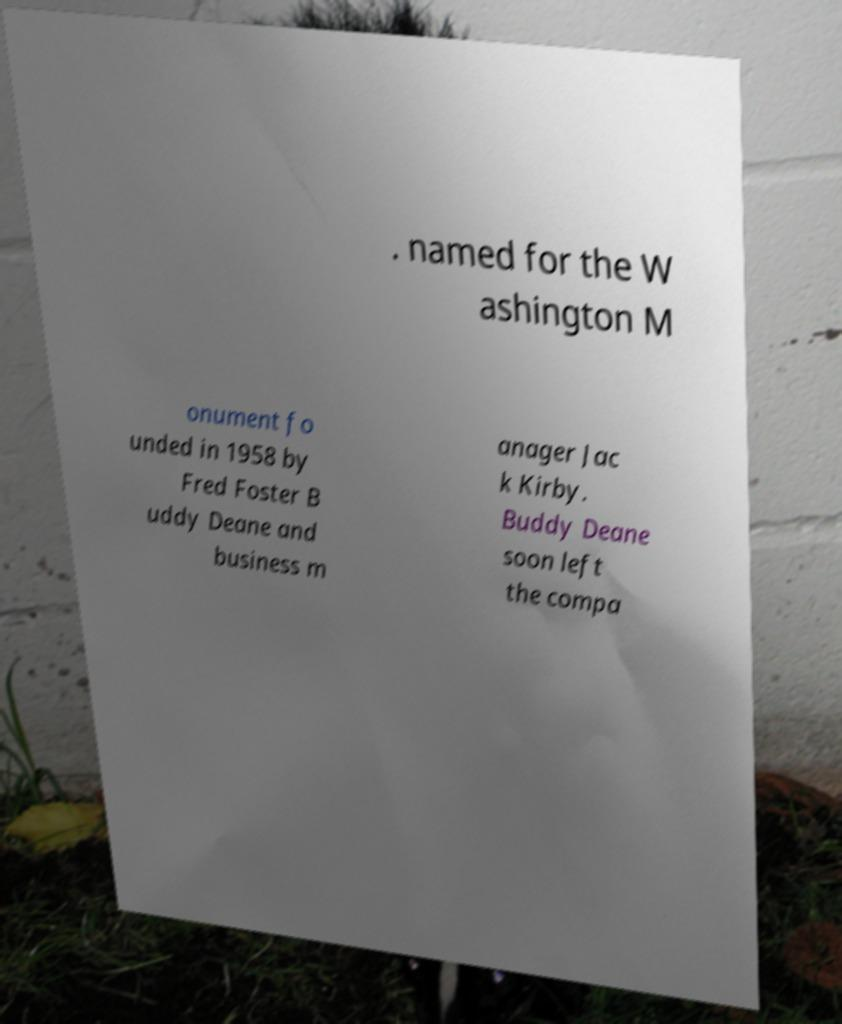Can you read and provide the text displayed in the image?This photo seems to have some interesting text. Can you extract and type it out for me? . named for the W ashington M onument fo unded in 1958 by Fred Foster B uddy Deane and business m anager Jac k Kirby. Buddy Deane soon left the compa 